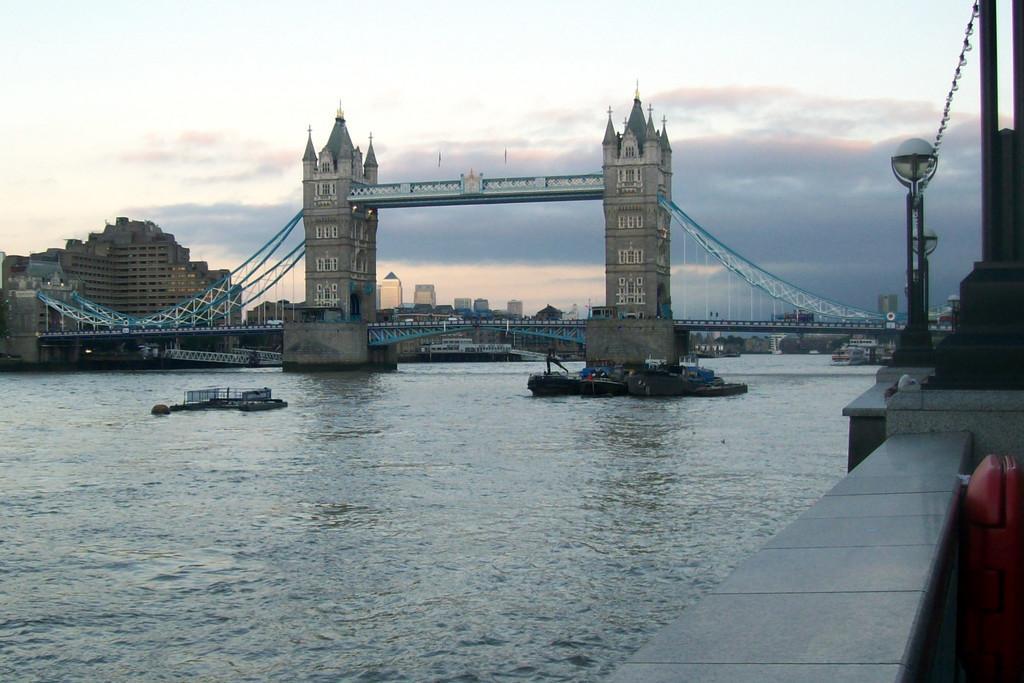Describe this image in one or two sentences. In the image we can see buildings and windows of the buildings, water, boat in the water, light pole, bridge and a cloudy sky. 